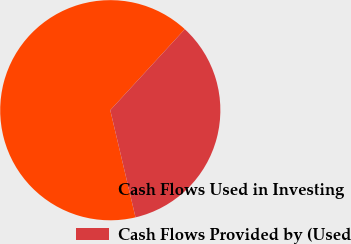<chart> <loc_0><loc_0><loc_500><loc_500><pie_chart><fcel>Cash Flows Used in Investing<fcel>Cash Flows Provided by (Used<nl><fcel>65.52%<fcel>34.48%<nl></chart> 